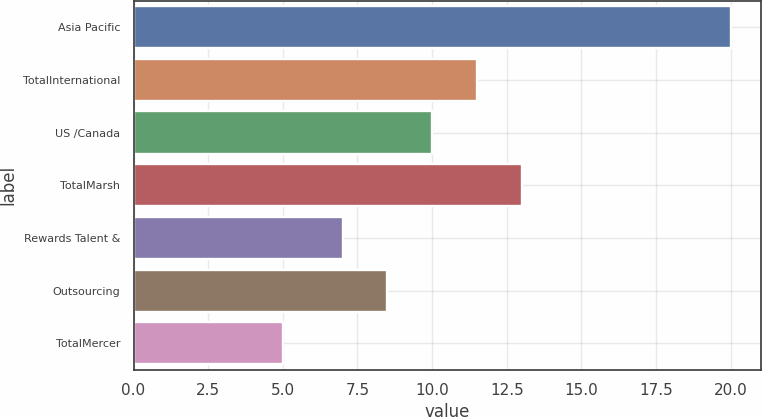Convert chart to OTSL. <chart><loc_0><loc_0><loc_500><loc_500><bar_chart><fcel>Asia Pacific<fcel>TotalInternational<fcel>US /Canada<fcel>TotalMarsh<fcel>Rewards Talent &<fcel>Outsourcing<fcel>TotalMercer<nl><fcel>20<fcel>11.5<fcel>10<fcel>13<fcel>7<fcel>8.5<fcel>5<nl></chart> 